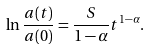<formula> <loc_0><loc_0><loc_500><loc_500>\ln \frac { a ( t ) } { a ( 0 ) } = \frac { S } { 1 - \alpha } t ^ { 1 - \alpha } .</formula> 